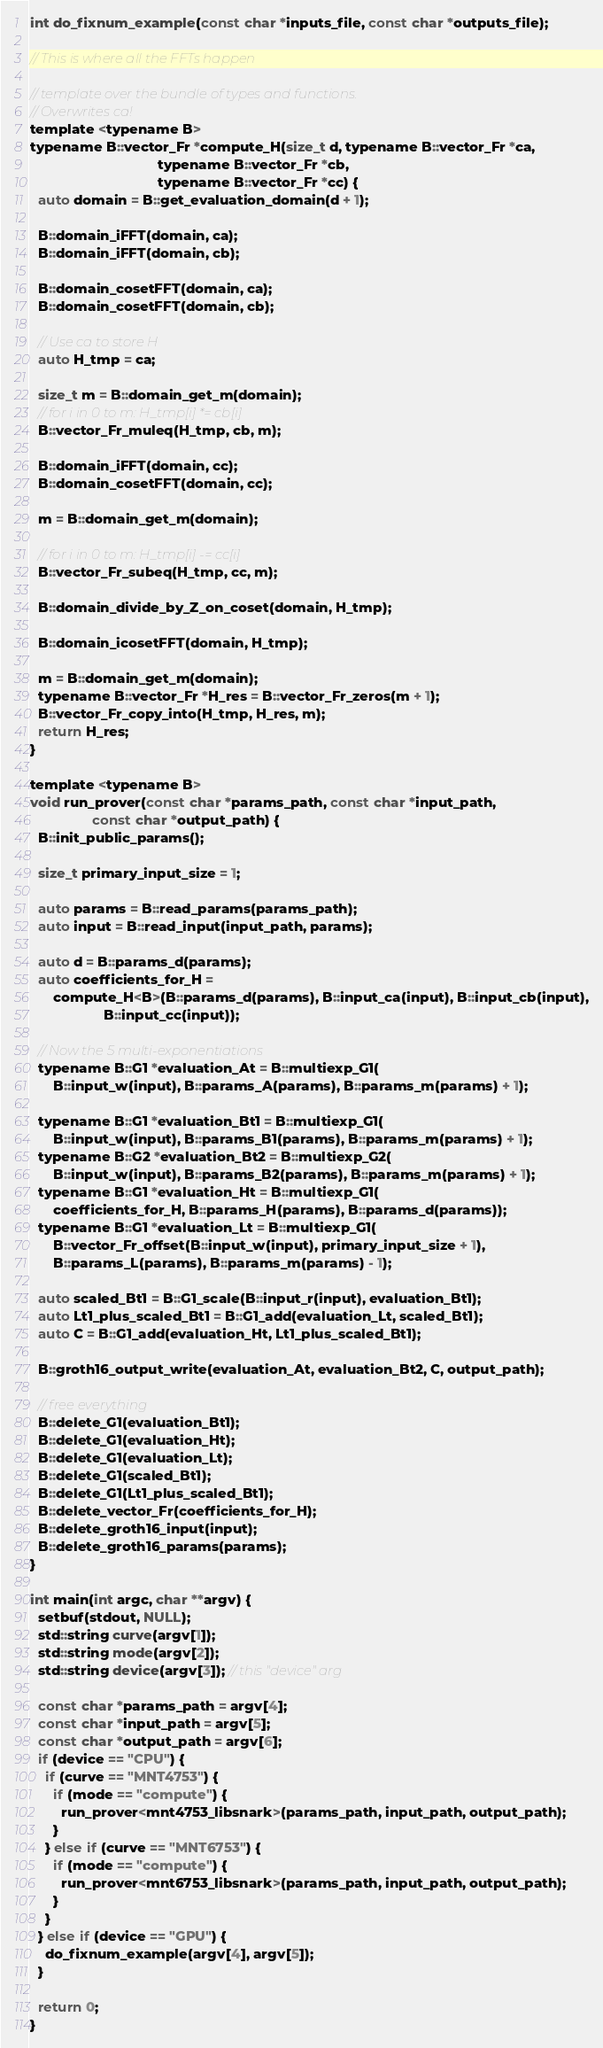<code> <loc_0><loc_0><loc_500><loc_500><_Cuda_>int do_fixnum_example(const char *inputs_file, const char *outputs_file);

// This is where all the FFTs happen

// template over the bundle of types and functions.
// Overwrites ca!
template <typename B>
typename B::vector_Fr *compute_H(size_t d, typename B::vector_Fr *ca,
                                 typename B::vector_Fr *cb,
                                 typename B::vector_Fr *cc) {
  auto domain = B::get_evaluation_domain(d + 1);

  B::domain_iFFT(domain, ca);
  B::domain_iFFT(domain, cb);

  B::domain_cosetFFT(domain, ca);
  B::domain_cosetFFT(domain, cb);

  // Use ca to store H
  auto H_tmp = ca;

  size_t m = B::domain_get_m(domain);
  // for i in 0 to m: H_tmp[i] *= cb[i]
  B::vector_Fr_muleq(H_tmp, cb, m);

  B::domain_iFFT(domain, cc);
  B::domain_cosetFFT(domain, cc);

  m = B::domain_get_m(domain);

  // for i in 0 to m: H_tmp[i] -= cc[i]
  B::vector_Fr_subeq(H_tmp, cc, m);

  B::domain_divide_by_Z_on_coset(domain, H_tmp);

  B::domain_icosetFFT(domain, H_tmp);

  m = B::domain_get_m(domain);
  typename B::vector_Fr *H_res = B::vector_Fr_zeros(m + 1);
  B::vector_Fr_copy_into(H_tmp, H_res, m);
  return H_res;
}

template <typename B>
void run_prover(const char *params_path, const char *input_path,
                const char *output_path) {
  B::init_public_params();

  size_t primary_input_size = 1;

  auto params = B::read_params(params_path);
  auto input = B::read_input(input_path, params);

  auto d = B::params_d(params);
  auto coefficients_for_H =
      compute_H<B>(B::params_d(params), B::input_ca(input), B::input_cb(input),
                   B::input_cc(input));

  // Now the 5 multi-exponentiations
  typename B::G1 *evaluation_At = B::multiexp_G1(
      B::input_w(input), B::params_A(params), B::params_m(params) + 1);

  typename B::G1 *evaluation_Bt1 = B::multiexp_G1(
      B::input_w(input), B::params_B1(params), B::params_m(params) + 1);
  typename B::G2 *evaluation_Bt2 = B::multiexp_G2(
      B::input_w(input), B::params_B2(params), B::params_m(params) + 1);
  typename B::G1 *evaluation_Ht = B::multiexp_G1(
      coefficients_for_H, B::params_H(params), B::params_d(params));
  typename B::G1 *evaluation_Lt = B::multiexp_G1(
      B::vector_Fr_offset(B::input_w(input), primary_input_size + 1),
      B::params_L(params), B::params_m(params) - 1);

  auto scaled_Bt1 = B::G1_scale(B::input_r(input), evaluation_Bt1);
  auto Lt1_plus_scaled_Bt1 = B::G1_add(evaluation_Lt, scaled_Bt1);
  auto C = B::G1_add(evaluation_Ht, Lt1_plus_scaled_Bt1);

  B::groth16_output_write(evaluation_At, evaluation_Bt2, C, output_path);

  // free everything
  B::delete_G1(evaluation_Bt1);
  B::delete_G1(evaluation_Ht);
  B::delete_G1(evaluation_Lt);
  B::delete_G1(scaled_Bt1);
  B::delete_G1(Lt1_plus_scaled_Bt1);
  B::delete_vector_Fr(coefficients_for_H);
  B::delete_groth16_input(input);
  B::delete_groth16_params(params);
}

int main(int argc, char **argv) {
  setbuf(stdout, NULL);
  std::string curve(argv[1]);
  std::string mode(argv[2]);
  std::string device(argv[3]); // this "device" arg

  const char *params_path = argv[4];
  const char *input_path = argv[5];
  const char *output_path = argv[6];
  if (device == "CPU") {
    if (curve == "MNT4753") {
      if (mode == "compute") {
        run_prover<mnt4753_libsnark>(params_path, input_path, output_path);
      }
    } else if (curve == "MNT6753") {
      if (mode == "compute") {
        run_prover<mnt6753_libsnark>(params_path, input_path, output_path);
      }
    }
  } else if (device == "GPU") {
    do_fixnum_example(argv[4], argv[5]);
  }

  return 0;
}
</code> 